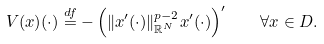<formula> <loc_0><loc_0><loc_500><loc_500>V ( x ) ( \cdot ) \stackrel { d f } { = } - \left ( \| x ^ { \prime } ( \cdot ) \| _ { \mathbb { R } ^ { N } } ^ { p - 2 } x ^ { \prime } ( \cdot ) \right ) ^ { \prime } \quad \forall x \in D .</formula> 